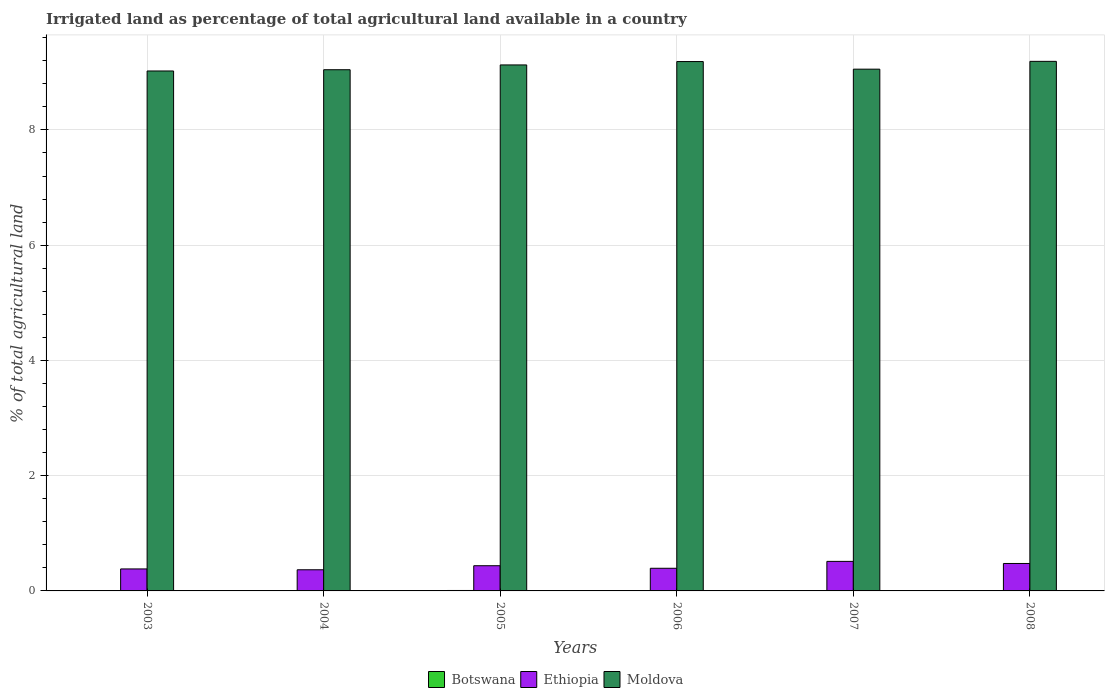How many groups of bars are there?
Offer a very short reply. 6. Are the number of bars on each tick of the X-axis equal?
Keep it short and to the point. Yes. How many bars are there on the 1st tick from the right?
Offer a terse response. 3. What is the label of the 3rd group of bars from the left?
Keep it short and to the point. 2005. In how many cases, is the number of bars for a given year not equal to the number of legend labels?
Keep it short and to the point. 0. What is the percentage of irrigated land in Moldova in 2003?
Keep it short and to the point. 9.02. Across all years, what is the maximum percentage of irrigated land in Ethiopia?
Offer a terse response. 0.51. Across all years, what is the minimum percentage of irrigated land in Botswana?
Offer a very short reply. 0. In which year was the percentage of irrigated land in Ethiopia maximum?
Provide a succinct answer. 2007. What is the total percentage of irrigated land in Botswana in the graph?
Your answer should be compact. 0.02. What is the difference between the percentage of irrigated land in Moldova in 2005 and that in 2008?
Offer a very short reply. -0.06. What is the difference between the percentage of irrigated land in Moldova in 2003 and the percentage of irrigated land in Ethiopia in 2006?
Provide a short and direct response. 8.63. What is the average percentage of irrigated land in Botswana per year?
Your answer should be compact. 0. In the year 2008, what is the difference between the percentage of irrigated land in Botswana and percentage of irrigated land in Moldova?
Your response must be concise. -9.18. What is the ratio of the percentage of irrigated land in Moldova in 2003 to that in 2008?
Offer a very short reply. 0.98. Is the percentage of irrigated land in Ethiopia in 2005 less than that in 2006?
Provide a succinct answer. No. Is the difference between the percentage of irrigated land in Botswana in 2005 and 2008 greater than the difference between the percentage of irrigated land in Moldova in 2005 and 2008?
Make the answer very short. Yes. What is the difference between the highest and the second highest percentage of irrigated land in Moldova?
Offer a terse response. 0. What is the difference between the highest and the lowest percentage of irrigated land in Moldova?
Give a very brief answer. 0.17. What does the 2nd bar from the left in 2003 represents?
Your response must be concise. Ethiopia. What does the 3rd bar from the right in 2006 represents?
Your answer should be very brief. Botswana. Is it the case that in every year, the sum of the percentage of irrigated land in Botswana and percentage of irrigated land in Moldova is greater than the percentage of irrigated land in Ethiopia?
Make the answer very short. Yes. How many years are there in the graph?
Offer a very short reply. 6. What is the difference between two consecutive major ticks on the Y-axis?
Provide a succinct answer. 2. How many legend labels are there?
Offer a terse response. 3. What is the title of the graph?
Make the answer very short. Irrigated land as percentage of total agricultural land available in a country. What is the label or title of the Y-axis?
Keep it short and to the point. % of total agricultural land. What is the % of total agricultural land of Botswana in 2003?
Your answer should be compact. 0. What is the % of total agricultural land in Ethiopia in 2003?
Ensure brevity in your answer.  0.38. What is the % of total agricultural land in Moldova in 2003?
Ensure brevity in your answer.  9.02. What is the % of total agricultural land of Botswana in 2004?
Provide a short and direct response. 0. What is the % of total agricultural land of Ethiopia in 2004?
Your answer should be very brief. 0.37. What is the % of total agricultural land in Moldova in 2004?
Your answer should be compact. 9.04. What is the % of total agricultural land in Botswana in 2005?
Offer a terse response. 0.01. What is the % of total agricultural land in Ethiopia in 2005?
Provide a succinct answer. 0.44. What is the % of total agricultural land in Moldova in 2005?
Provide a succinct answer. 9.13. What is the % of total agricultural land of Botswana in 2006?
Ensure brevity in your answer.  0. What is the % of total agricultural land in Ethiopia in 2006?
Give a very brief answer. 0.39. What is the % of total agricultural land in Moldova in 2006?
Offer a terse response. 9.19. What is the % of total agricultural land of Botswana in 2007?
Your response must be concise. 0. What is the % of total agricultural land of Ethiopia in 2007?
Provide a succinct answer. 0.51. What is the % of total agricultural land in Moldova in 2007?
Ensure brevity in your answer.  9.05. What is the % of total agricultural land in Botswana in 2008?
Your answer should be very brief. 0.01. What is the % of total agricultural land in Ethiopia in 2008?
Keep it short and to the point. 0.48. What is the % of total agricultural land in Moldova in 2008?
Ensure brevity in your answer.  9.19. Across all years, what is the maximum % of total agricultural land in Botswana?
Provide a succinct answer. 0.01. Across all years, what is the maximum % of total agricultural land in Ethiopia?
Offer a very short reply. 0.51. Across all years, what is the maximum % of total agricultural land in Moldova?
Provide a succinct answer. 9.19. Across all years, what is the minimum % of total agricultural land of Botswana?
Offer a very short reply. 0. Across all years, what is the minimum % of total agricultural land of Ethiopia?
Offer a terse response. 0.37. Across all years, what is the minimum % of total agricultural land in Moldova?
Give a very brief answer. 9.02. What is the total % of total agricultural land in Botswana in the graph?
Provide a succinct answer. 0.02. What is the total % of total agricultural land in Ethiopia in the graph?
Keep it short and to the point. 2.57. What is the total % of total agricultural land of Moldova in the graph?
Provide a succinct answer. 54.63. What is the difference between the % of total agricultural land in Botswana in 2003 and that in 2004?
Your response must be concise. -0. What is the difference between the % of total agricultural land of Ethiopia in 2003 and that in 2004?
Keep it short and to the point. 0.01. What is the difference between the % of total agricultural land in Moldova in 2003 and that in 2004?
Provide a succinct answer. -0.02. What is the difference between the % of total agricultural land in Botswana in 2003 and that in 2005?
Keep it short and to the point. -0.01. What is the difference between the % of total agricultural land of Ethiopia in 2003 and that in 2005?
Keep it short and to the point. -0.06. What is the difference between the % of total agricultural land in Moldova in 2003 and that in 2005?
Keep it short and to the point. -0.1. What is the difference between the % of total agricultural land in Botswana in 2003 and that in 2006?
Your response must be concise. -0. What is the difference between the % of total agricultural land of Ethiopia in 2003 and that in 2006?
Provide a short and direct response. -0.01. What is the difference between the % of total agricultural land of Moldova in 2003 and that in 2006?
Keep it short and to the point. -0.16. What is the difference between the % of total agricultural land in Botswana in 2003 and that in 2007?
Offer a terse response. -0. What is the difference between the % of total agricultural land of Ethiopia in 2003 and that in 2007?
Give a very brief answer. -0.13. What is the difference between the % of total agricultural land in Moldova in 2003 and that in 2007?
Your response must be concise. -0.03. What is the difference between the % of total agricultural land of Botswana in 2003 and that in 2008?
Your response must be concise. -0.01. What is the difference between the % of total agricultural land in Ethiopia in 2003 and that in 2008?
Give a very brief answer. -0.09. What is the difference between the % of total agricultural land of Moldova in 2003 and that in 2008?
Provide a short and direct response. -0.17. What is the difference between the % of total agricultural land of Botswana in 2004 and that in 2005?
Your answer should be compact. -0.01. What is the difference between the % of total agricultural land in Ethiopia in 2004 and that in 2005?
Provide a short and direct response. -0.07. What is the difference between the % of total agricultural land of Moldova in 2004 and that in 2005?
Ensure brevity in your answer.  -0.08. What is the difference between the % of total agricultural land of Botswana in 2004 and that in 2006?
Make the answer very short. -0. What is the difference between the % of total agricultural land in Ethiopia in 2004 and that in 2006?
Offer a terse response. -0.03. What is the difference between the % of total agricultural land of Moldova in 2004 and that in 2006?
Make the answer very short. -0.14. What is the difference between the % of total agricultural land in Botswana in 2004 and that in 2007?
Keep it short and to the point. 0. What is the difference between the % of total agricultural land in Ethiopia in 2004 and that in 2007?
Provide a succinct answer. -0.15. What is the difference between the % of total agricultural land in Moldova in 2004 and that in 2007?
Your answer should be very brief. -0.01. What is the difference between the % of total agricultural land in Botswana in 2004 and that in 2008?
Provide a short and direct response. -0. What is the difference between the % of total agricultural land in Ethiopia in 2004 and that in 2008?
Provide a succinct answer. -0.11. What is the difference between the % of total agricultural land of Moldova in 2004 and that in 2008?
Offer a very short reply. -0.15. What is the difference between the % of total agricultural land of Botswana in 2005 and that in 2006?
Your answer should be compact. 0.01. What is the difference between the % of total agricultural land in Ethiopia in 2005 and that in 2006?
Make the answer very short. 0.04. What is the difference between the % of total agricultural land in Moldova in 2005 and that in 2006?
Give a very brief answer. -0.06. What is the difference between the % of total agricultural land in Botswana in 2005 and that in 2007?
Provide a succinct answer. 0.01. What is the difference between the % of total agricultural land in Ethiopia in 2005 and that in 2007?
Ensure brevity in your answer.  -0.08. What is the difference between the % of total agricultural land of Moldova in 2005 and that in 2007?
Make the answer very short. 0.07. What is the difference between the % of total agricultural land of Botswana in 2005 and that in 2008?
Ensure brevity in your answer.  0. What is the difference between the % of total agricultural land in Ethiopia in 2005 and that in 2008?
Make the answer very short. -0.04. What is the difference between the % of total agricultural land of Moldova in 2005 and that in 2008?
Ensure brevity in your answer.  -0.06. What is the difference between the % of total agricultural land in Ethiopia in 2006 and that in 2007?
Make the answer very short. -0.12. What is the difference between the % of total agricultural land in Moldova in 2006 and that in 2007?
Provide a succinct answer. 0.13. What is the difference between the % of total agricultural land in Botswana in 2006 and that in 2008?
Offer a terse response. -0. What is the difference between the % of total agricultural land in Ethiopia in 2006 and that in 2008?
Provide a short and direct response. -0.08. What is the difference between the % of total agricultural land in Moldova in 2006 and that in 2008?
Ensure brevity in your answer.  -0. What is the difference between the % of total agricultural land of Botswana in 2007 and that in 2008?
Provide a short and direct response. -0.01. What is the difference between the % of total agricultural land in Ethiopia in 2007 and that in 2008?
Offer a very short reply. 0.04. What is the difference between the % of total agricultural land in Moldova in 2007 and that in 2008?
Keep it short and to the point. -0.14. What is the difference between the % of total agricultural land of Botswana in 2003 and the % of total agricultural land of Ethiopia in 2004?
Provide a short and direct response. -0.37. What is the difference between the % of total agricultural land in Botswana in 2003 and the % of total agricultural land in Moldova in 2004?
Your answer should be compact. -9.04. What is the difference between the % of total agricultural land of Ethiopia in 2003 and the % of total agricultural land of Moldova in 2004?
Give a very brief answer. -8.66. What is the difference between the % of total agricultural land of Botswana in 2003 and the % of total agricultural land of Ethiopia in 2005?
Offer a very short reply. -0.44. What is the difference between the % of total agricultural land in Botswana in 2003 and the % of total agricultural land in Moldova in 2005?
Ensure brevity in your answer.  -9.13. What is the difference between the % of total agricultural land of Ethiopia in 2003 and the % of total agricultural land of Moldova in 2005?
Offer a very short reply. -8.75. What is the difference between the % of total agricultural land of Botswana in 2003 and the % of total agricultural land of Ethiopia in 2006?
Offer a terse response. -0.39. What is the difference between the % of total agricultural land in Botswana in 2003 and the % of total agricultural land in Moldova in 2006?
Give a very brief answer. -9.19. What is the difference between the % of total agricultural land of Ethiopia in 2003 and the % of total agricultural land of Moldova in 2006?
Ensure brevity in your answer.  -8.8. What is the difference between the % of total agricultural land in Botswana in 2003 and the % of total agricultural land in Ethiopia in 2007?
Provide a succinct answer. -0.51. What is the difference between the % of total agricultural land of Botswana in 2003 and the % of total agricultural land of Moldova in 2007?
Make the answer very short. -9.05. What is the difference between the % of total agricultural land of Ethiopia in 2003 and the % of total agricultural land of Moldova in 2007?
Your answer should be compact. -8.67. What is the difference between the % of total agricultural land of Botswana in 2003 and the % of total agricultural land of Ethiopia in 2008?
Provide a short and direct response. -0.48. What is the difference between the % of total agricultural land in Botswana in 2003 and the % of total agricultural land in Moldova in 2008?
Ensure brevity in your answer.  -9.19. What is the difference between the % of total agricultural land in Ethiopia in 2003 and the % of total agricultural land in Moldova in 2008?
Provide a short and direct response. -8.81. What is the difference between the % of total agricultural land of Botswana in 2004 and the % of total agricultural land of Ethiopia in 2005?
Make the answer very short. -0.44. What is the difference between the % of total agricultural land of Botswana in 2004 and the % of total agricultural land of Moldova in 2005?
Offer a terse response. -9.13. What is the difference between the % of total agricultural land of Ethiopia in 2004 and the % of total agricultural land of Moldova in 2005?
Keep it short and to the point. -8.76. What is the difference between the % of total agricultural land in Botswana in 2004 and the % of total agricultural land in Ethiopia in 2006?
Ensure brevity in your answer.  -0.39. What is the difference between the % of total agricultural land in Botswana in 2004 and the % of total agricultural land in Moldova in 2006?
Provide a succinct answer. -9.19. What is the difference between the % of total agricultural land of Ethiopia in 2004 and the % of total agricultural land of Moldova in 2006?
Offer a terse response. -8.82. What is the difference between the % of total agricultural land in Botswana in 2004 and the % of total agricultural land in Ethiopia in 2007?
Offer a very short reply. -0.51. What is the difference between the % of total agricultural land in Botswana in 2004 and the % of total agricultural land in Moldova in 2007?
Offer a very short reply. -9.05. What is the difference between the % of total agricultural land in Ethiopia in 2004 and the % of total agricultural land in Moldova in 2007?
Offer a terse response. -8.69. What is the difference between the % of total agricultural land of Botswana in 2004 and the % of total agricultural land of Ethiopia in 2008?
Provide a short and direct response. -0.48. What is the difference between the % of total agricultural land in Botswana in 2004 and the % of total agricultural land in Moldova in 2008?
Offer a terse response. -9.19. What is the difference between the % of total agricultural land in Ethiopia in 2004 and the % of total agricultural land in Moldova in 2008?
Your answer should be compact. -8.82. What is the difference between the % of total agricultural land in Botswana in 2005 and the % of total agricultural land in Ethiopia in 2006?
Keep it short and to the point. -0.39. What is the difference between the % of total agricultural land of Botswana in 2005 and the % of total agricultural land of Moldova in 2006?
Offer a very short reply. -9.18. What is the difference between the % of total agricultural land of Ethiopia in 2005 and the % of total agricultural land of Moldova in 2006?
Provide a short and direct response. -8.75. What is the difference between the % of total agricultural land in Botswana in 2005 and the % of total agricultural land in Ethiopia in 2007?
Provide a succinct answer. -0.5. What is the difference between the % of total agricultural land of Botswana in 2005 and the % of total agricultural land of Moldova in 2007?
Your answer should be very brief. -9.05. What is the difference between the % of total agricultural land in Ethiopia in 2005 and the % of total agricultural land in Moldova in 2007?
Your answer should be very brief. -8.62. What is the difference between the % of total agricultural land in Botswana in 2005 and the % of total agricultural land in Ethiopia in 2008?
Ensure brevity in your answer.  -0.47. What is the difference between the % of total agricultural land of Botswana in 2005 and the % of total agricultural land of Moldova in 2008?
Your response must be concise. -9.18. What is the difference between the % of total agricultural land of Ethiopia in 2005 and the % of total agricultural land of Moldova in 2008?
Your answer should be very brief. -8.75. What is the difference between the % of total agricultural land of Botswana in 2006 and the % of total agricultural land of Ethiopia in 2007?
Offer a terse response. -0.51. What is the difference between the % of total agricultural land of Botswana in 2006 and the % of total agricultural land of Moldova in 2007?
Keep it short and to the point. -9.05. What is the difference between the % of total agricultural land in Ethiopia in 2006 and the % of total agricultural land in Moldova in 2007?
Provide a short and direct response. -8.66. What is the difference between the % of total agricultural land of Botswana in 2006 and the % of total agricultural land of Ethiopia in 2008?
Your answer should be very brief. -0.48. What is the difference between the % of total agricultural land of Botswana in 2006 and the % of total agricultural land of Moldova in 2008?
Offer a very short reply. -9.19. What is the difference between the % of total agricultural land in Ethiopia in 2006 and the % of total agricultural land in Moldova in 2008?
Make the answer very short. -8.8. What is the difference between the % of total agricultural land in Botswana in 2007 and the % of total agricultural land in Ethiopia in 2008?
Your answer should be compact. -0.48. What is the difference between the % of total agricultural land of Botswana in 2007 and the % of total agricultural land of Moldova in 2008?
Give a very brief answer. -9.19. What is the difference between the % of total agricultural land in Ethiopia in 2007 and the % of total agricultural land in Moldova in 2008?
Your answer should be very brief. -8.68. What is the average % of total agricultural land of Botswana per year?
Offer a very short reply. 0. What is the average % of total agricultural land of Ethiopia per year?
Keep it short and to the point. 0.43. What is the average % of total agricultural land in Moldova per year?
Your answer should be very brief. 9.1. In the year 2003, what is the difference between the % of total agricultural land of Botswana and % of total agricultural land of Ethiopia?
Provide a short and direct response. -0.38. In the year 2003, what is the difference between the % of total agricultural land in Botswana and % of total agricultural land in Moldova?
Your answer should be very brief. -9.02. In the year 2003, what is the difference between the % of total agricultural land in Ethiopia and % of total agricultural land in Moldova?
Offer a terse response. -8.64. In the year 2004, what is the difference between the % of total agricultural land of Botswana and % of total agricultural land of Ethiopia?
Your answer should be very brief. -0.37. In the year 2004, what is the difference between the % of total agricultural land of Botswana and % of total agricultural land of Moldova?
Your response must be concise. -9.04. In the year 2004, what is the difference between the % of total agricultural land of Ethiopia and % of total agricultural land of Moldova?
Offer a terse response. -8.68. In the year 2005, what is the difference between the % of total agricultural land of Botswana and % of total agricultural land of Ethiopia?
Give a very brief answer. -0.43. In the year 2005, what is the difference between the % of total agricultural land in Botswana and % of total agricultural land in Moldova?
Provide a succinct answer. -9.12. In the year 2005, what is the difference between the % of total agricultural land in Ethiopia and % of total agricultural land in Moldova?
Ensure brevity in your answer.  -8.69. In the year 2006, what is the difference between the % of total agricultural land in Botswana and % of total agricultural land in Ethiopia?
Give a very brief answer. -0.39. In the year 2006, what is the difference between the % of total agricultural land of Botswana and % of total agricultural land of Moldova?
Ensure brevity in your answer.  -9.19. In the year 2006, what is the difference between the % of total agricultural land of Ethiopia and % of total agricultural land of Moldova?
Offer a very short reply. -8.79. In the year 2007, what is the difference between the % of total agricultural land of Botswana and % of total agricultural land of Ethiopia?
Offer a terse response. -0.51. In the year 2007, what is the difference between the % of total agricultural land in Botswana and % of total agricultural land in Moldova?
Your response must be concise. -9.05. In the year 2007, what is the difference between the % of total agricultural land of Ethiopia and % of total agricultural land of Moldova?
Make the answer very short. -8.54. In the year 2008, what is the difference between the % of total agricultural land of Botswana and % of total agricultural land of Ethiopia?
Give a very brief answer. -0.47. In the year 2008, what is the difference between the % of total agricultural land in Botswana and % of total agricultural land in Moldova?
Ensure brevity in your answer.  -9.18. In the year 2008, what is the difference between the % of total agricultural land of Ethiopia and % of total agricultural land of Moldova?
Make the answer very short. -8.71. What is the ratio of the % of total agricultural land in Botswana in 2003 to that in 2004?
Ensure brevity in your answer.  0.47. What is the ratio of the % of total agricultural land in Ethiopia in 2003 to that in 2004?
Offer a very short reply. 1.04. What is the ratio of the % of total agricultural land in Moldova in 2003 to that in 2004?
Your response must be concise. 1. What is the ratio of the % of total agricultural land of Botswana in 2003 to that in 2005?
Make the answer very short. 0.07. What is the ratio of the % of total agricultural land of Ethiopia in 2003 to that in 2005?
Your answer should be compact. 0.87. What is the ratio of the % of total agricultural land of Moldova in 2003 to that in 2005?
Offer a terse response. 0.99. What is the ratio of the % of total agricultural land in Botswana in 2003 to that in 2006?
Make the answer very short. 0.47. What is the ratio of the % of total agricultural land in Ethiopia in 2003 to that in 2006?
Your response must be concise. 0.97. What is the ratio of the % of total agricultural land of Moldova in 2003 to that in 2006?
Provide a short and direct response. 0.98. What is the ratio of the % of total agricultural land of Botswana in 2003 to that in 2007?
Offer a terse response. 0.67. What is the ratio of the % of total agricultural land of Ethiopia in 2003 to that in 2007?
Make the answer very short. 0.74. What is the ratio of the % of total agricultural land in Moldova in 2003 to that in 2007?
Your response must be concise. 1. What is the ratio of the % of total agricultural land in Botswana in 2003 to that in 2008?
Provide a short and direct response. 0.09. What is the ratio of the % of total agricultural land of Ethiopia in 2003 to that in 2008?
Keep it short and to the point. 0.8. What is the ratio of the % of total agricultural land of Moldova in 2003 to that in 2008?
Your answer should be very brief. 0.98. What is the ratio of the % of total agricultural land in Botswana in 2004 to that in 2005?
Your answer should be very brief. 0.15. What is the ratio of the % of total agricultural land of Ethiopia in 2004 to that in 2005?
Make the answer very short. 0.84. What is the ratio of the % of total agricultural land of Moldova in 2004 to that in 2005?
Your response must be concise. 0.99. What is the ratio of the % of total agricultural land of Ethiopia in 2004 to that in 2006?
Provide a succinct answer. 0.93. What is the ratio of the % of total agricultural land of Moldova in 2004 to that in 2006?
Offer a terse response. 0.98. What is the ratio of the % of total agricultural land in Botswana in 2004 to that in 2007?
Keep it short and to the point. 1.43. What is the ratio of the % of total agricultural land of Ethiopia in 2004 to that in 2007?
Your response must be concise. 0.72. What is the ratio of the % of total agricultural land in Botswana in 2004 to that in 2008?
Make the answer very short. 0.2. What is the ratio of the % of total agricultural land in Ethiopia in 2004 to that in 2008?
Make the answer very short. 0.77. What is the ratio of the % of total agricultural land of Moldova in 2004 to that in 2008?
Ensure brevity in your answer.  0.98. What is the ratio of the % of total agricultural land of Botswana in 2005 to that in 2006?
Offer a very short reply. 6.66. What is the ratio of the % of total agricultural land of Ethiopia in 2005 to that in 2006?
Offer a terse response. 1.11. What is the ratio of the % of total agricultural land in Botswana in 2005 to that in 2007?
Provide a short and direct response. 9.5. What is the ratio of the % of total agricultural land in Ethiopia in 2005 to that in 2007?
Provide a succinct answer. 0.85. What is the ratio of the % of total agricultural land of Moldova in 2005 to that in 2007?
Keep it short and to the point. 1.01. What is the ratio of the % of total agricultural land in Botswana in 2005 to that in 2008?
Your answer should be very brief. 1.34. What is the ratio of the % of total agricultural land in Ethiopia in 2005 to that in 2008?
Offer a terse response. 0.92. What is the ratio of the % of total agricultural land in Botswana in 2006 to that in 2007?
Give a very brief answer. 1.43. What is the ratio of the % of total agricultural land of Ethiopia in 2006 to that in 2007?
Your answer should be very brief. 0.77. What is the ratio of the % of total agricultural land in Moldova in 2006 to that in 2007?
Your answer should be compact. 1.01. What is the ratio of the % of total agricultural land in Botswana in 2006 to that in 2008?
Your answer should be very brief. 0.2. What is the ratio of the % of total agricultural land of Ethiopia in 2006 to that in 2008?
Your response must be concise. 0.83. What is the ratio of the % of total agricultural land of Moldova in 2006 to that in 2008?
Give a very brief answer. 1. What is the ratio of the % of total agricultural land in Botswana in 2007 to that in 2008?
Keep it short and to the point. 0.14. What is the ratio of the % of total agricultural land in Ethiopia in 2007 to that in 2008?
Your answer should be very brief. 1.08. What is the ratio of the % of total agricultural land of Moldova in 2007 to that in 2008?
Your answer should be compact. 0.99. What is the difference between the highest and the second highest % of total agricultural land in Botswana?
Your answer should be compact. 0. What is the difference between the highest and the second highest % of total agricultural land of Ethiopia?
Give a very brief answer. 0.04. What is the difference between the highest and the second highest % of total agricultural land of Moldova?
Your answer should be very brief. 0. What is the difference between the highest and the lowest % of total agricultural land in Botswana?
Your answer should be very brief. 0.01. What is the difference between the highest and the lowest % of total agricultural land in Ethiopia?
Your response must be concise. 0.15. What is the difference between the highest and the lowest % of total agricultural land in Moldova?
Keep it short and to the point. 0.17. 